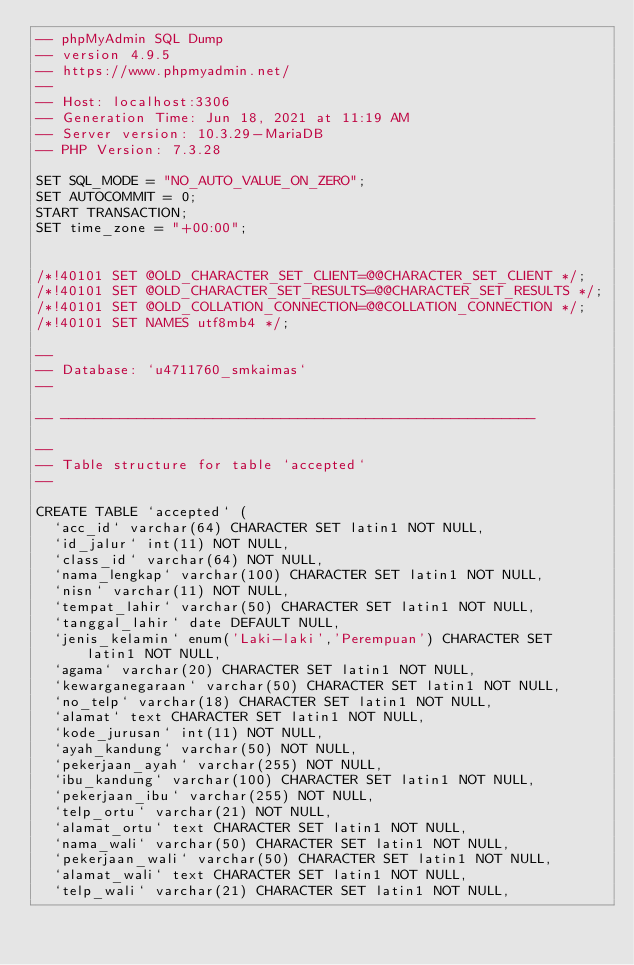<code> <loc_0><loc_0><loc_500><loc_500><_SQL_>-- phpMyAdmin SQL Dump
-- version 4.9.5
-- https://www.phpmyadmin.net/
--
-- Host: localhost:3306
-- Generation Time: Jun 18, 2021 at 11:19 AM
-- Server version: 10.3.29-MariaDB
-- PHP Version: 7.3.28

SET SQL_MODE = "NO_AUTO_VALUE_ON_ZERO";
SET AUTOCOMMIT = 0;
START TRANSACTION;
SET time_zone = "+00:00";


/*!40101 SET @OLD_CHARACTER_SET_CLIENT=@@CHARACTER_SET_CLIENT */;
/*!40101 SET @OLD_CHARACTER_SET_RESULTS=@@CHARACTER_SET_RESULTS */;
/*!40101 SET @OLD_COLLATION_CONNECTION=@@COLLATION_CONNECTION */;
/*!40101 SET NAMES utf8mb4 */;

--
-- Database: `u4711760_smkaimas`
--

-- --------------------------------------------------------

--
-- Table structure for table `accepted`
--

CREATE TABLE `accepted` (
  `acc_id` varchar(64) CHARACTER SET latin1 NOT NULL,
  `id_jalur` int(11) NOT NULL,
  `class_id` varchar(64) NOT NULL,
  `nama_lengkap` varchar(100) CHARACTER SET latin1 NOT NULL,
  `nisn` varchar(11) NOT NULL,
  `tempat_lahir` varchar(50) CHARACTER SET latin1 NOT NULL,
  `tanggal_lahir` date DEFAULT NULL,
  `jenis_kelamin` enum('Laki-laki','Perempuan') CHARACTER SET latin1 NOT NULL,
  `agama` varchar(20) CHARACTER SET latin1 NOT NULL,
  `kewarganegaraan` varchar(50) CHARACTER SET latin1 NOT NULL,
  `no_telp` varchar(18) CHARACTER SET latin1 NOT NULL,
  `alamat` text CHARACTER SET latin1 NOT NULL,
  `kode_jurusan` int(11) NOT NULL,
  `ayah_kandung` varchar(50) NOT NULL,
  `pekerjaan_ayah` varchar(255) NOT NULL,
  `ibu_kandung` varchar(100) CHARACTER SET latin1 NOT NULL,
  `pekerjaan_ibu` varchar(255) NOT NULL,
  `telp_ortu` varchar(21) NOT NULL,
  `alamat_ortu` text CHARACTER SET latin1 NOT NULL,
  `nama_wali` varchar(50) CHARACTER SET latin1 NOT NULL,
  `pekerjaan_wali` varchar(50) CHARACTER SET latin1 NOT NULL,
  `alamat_wali` text CHARACTER SET latin1 NOT NULL,
  `telp_wali` varchar(21) CHARACTER SET latin1 NOT NULL,</code> 